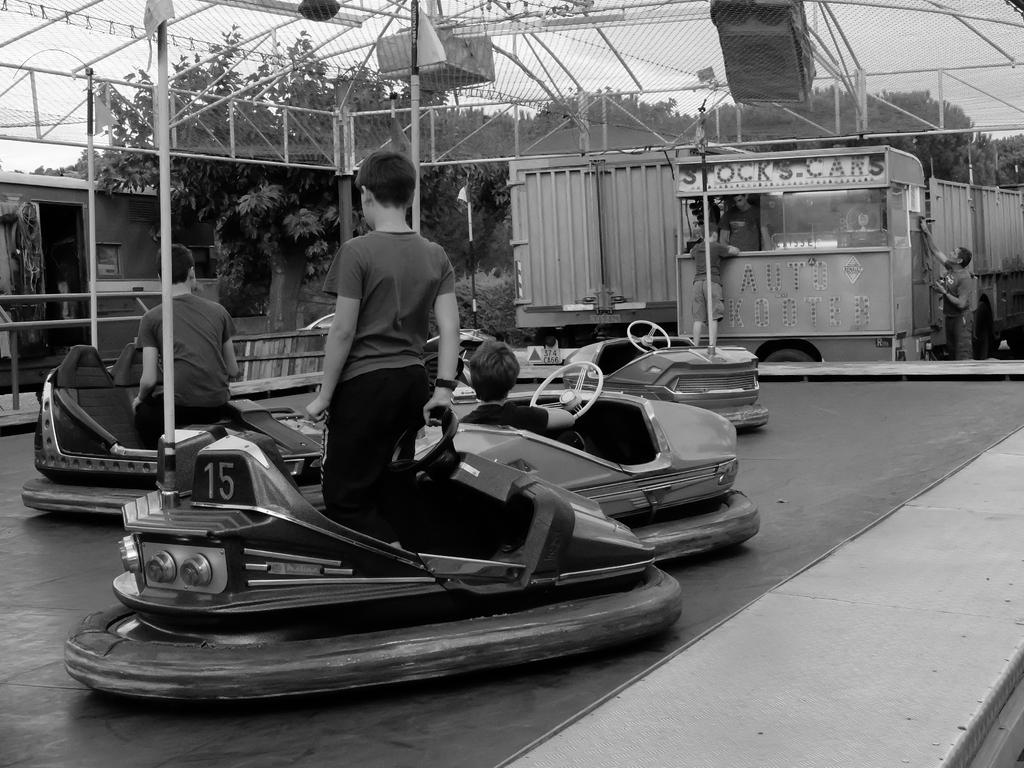What type of surface is visible in the image? There is a floor in the image. What toys are present in the image? There are battery operated cars in the image. Who or what can be seen in the image? There are people in the image. What type of vegetation is visible in the background of the image? There are trees in the background of the image. What type of barrier is present at the top of the image? There is metal fencing at the top of the image. What part of the natural environment is visible in the image? The sky is visible in the image. What type of amusement is the cook preparing in the image? There is no cook or amusement present in the image. What color is the sky in the image? The provided facts do not mention the color of the sky, only that it is visible. 